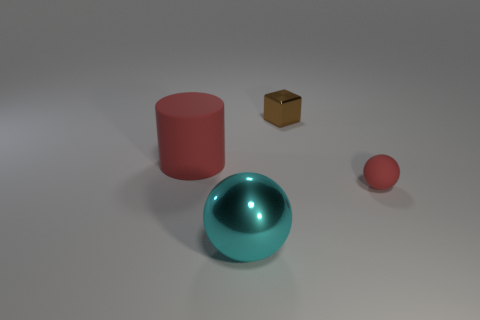The red rubber thing that is in front of the big red matte thing has what shape?
Your answer should be compact. Sphere. The tiny matte sphere is what color?
Provide a short and direct response. Red. There is a large sphere that is the same material as the brown object; what color is it?
Provide a succinct answer. Cyan. How many tiny objects are the same material as the large cylinder?
Give a very brief answer. 1. What number of cyan shiny objects are right of the cyan thing?
Offer a terse response. 0. Do the large thing that is to the left of the metallic ball and the ball that is behind the large cyan shiny object have the same material?
Keep it short and to the point. Yes. Are there more metal spheres left of the small matte thing than brown objects in front of the small cube?
Provide a succinct answer. Yes. There is a tiny ball that is the same color as the rubber cylinder; what is its material?
Your answer should be compact. Rubber. Are there any other things that have the same shape as the tiny brown thing?
Make the answer very short. No. What is the thing that is both behind the cyan ball and left of the tiny metal thing made of?
Ensure brevity in your answer.  Rubber. 